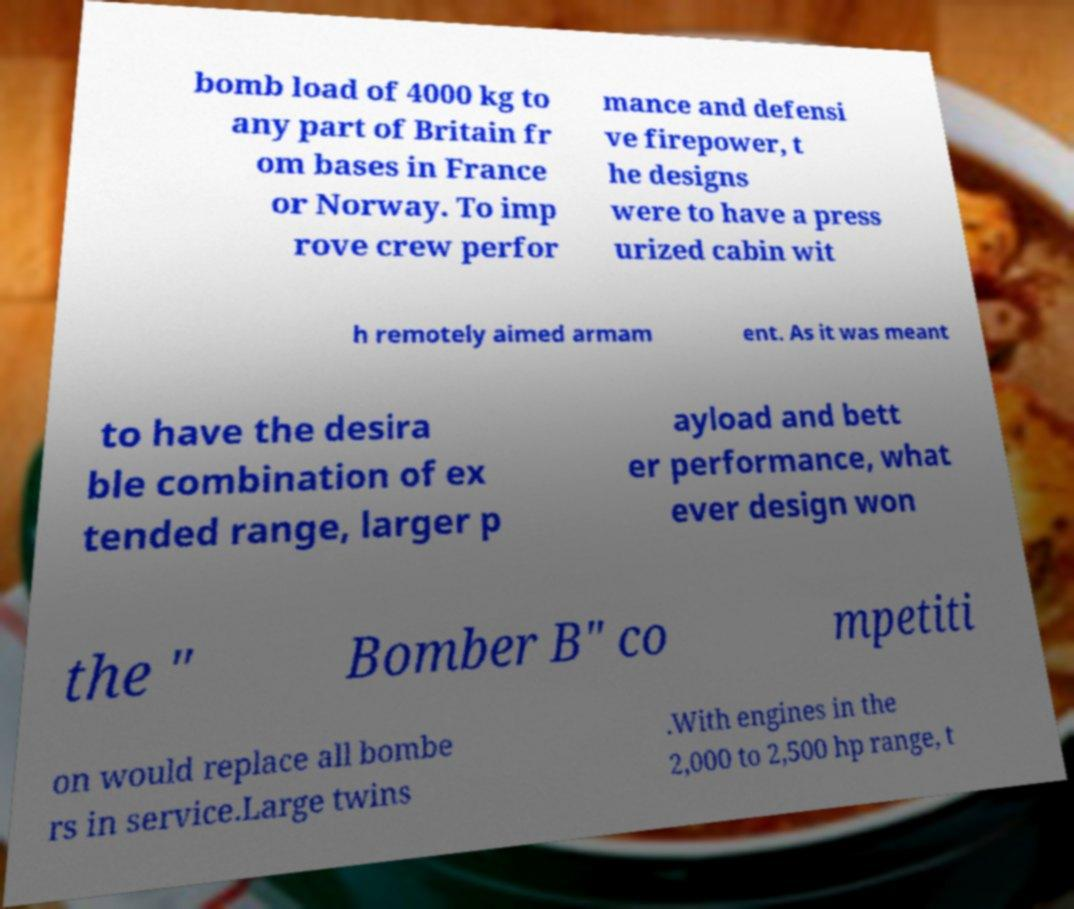Please read and relay the text visible in this image. What does it say? bomb load of 4000 kg to any part of Britain fr om bases in France or Norway. To imp rove crew perfor mance and defensi ve firepower, t he designs were to have a press urized cabin wit h remotely aimed armam ent. As it was meant to have the desira ble combination of ex tended range, larger p ayload and bett er performance, what ever design won the " Bomber B" co mpetiti on would replace all bombe rs in service.Large twins .With engines in the 2,000 to 2,500 hp range, t 